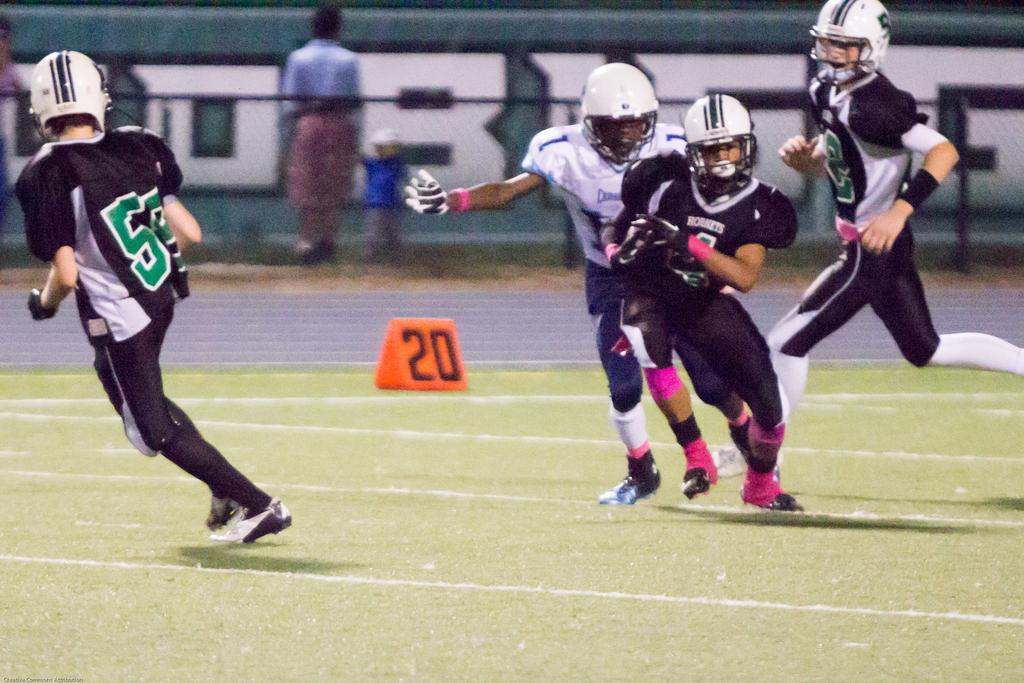What type of vegetation is at the bottom of the image? There is green grass at the bottom of the image. Who or what is in the foreground of the image? There are people in the foreground of the image. Who or what is in the background of the image? There are people in the background of the image. What can be seen on the poster in the background of the image? There is a poster with some text in the background of the image. What type of waste is visible in the image? There is no waste visible in the image. What meal is being prepared by the people in the image? The image does not show any meal preparation or consumption. 